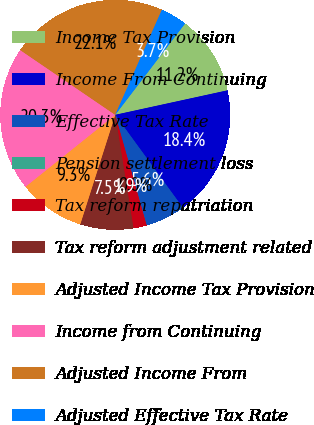Convert chart to OTSL. <chart><loc_0><loc_0><loc_500><loc_500><pie_chart><fcel>Income Tax Provision<fcel>Income From Continuing<fcel>Effective Tax Rate<fcel>Pension settlement loss<fcel>Tax reform repatriation<fcel>Tax reform adjustment related<fcel>Adjusted Income Tax Provision<fcel>Income from Continuing<fcel>Adjusted Income From<fcel>Adjusted Effective Tax Rate<nl><fcel>11.19%<fcel>18.4%<fcel>5.6%<fcel>0.01%<fcel>1.87%<fcel>7.46%<fcel>9.33%<fcel>20.27%<fcel>22.13%<fcel>3.74%<nl></chart> 